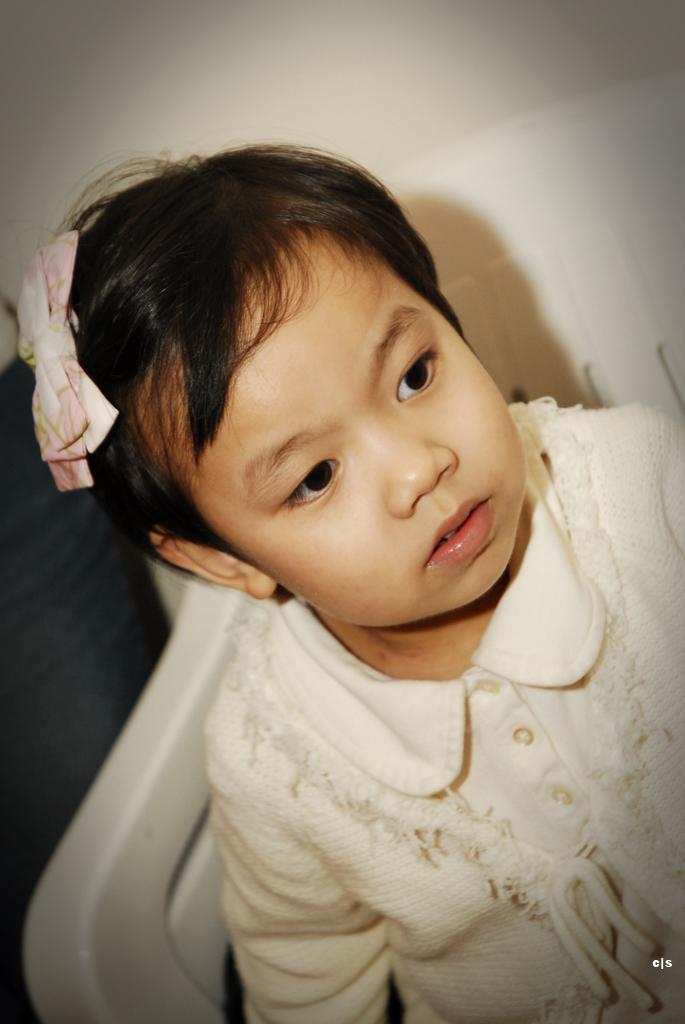Who is the main subject in the image? There is a girl in the image. What is the girl wearing? The girl is wearing a white dress. What is the girl sitting on? The girl is sitting on a white chair. What color is the wall in the background? The wall in the background is white. What is the color of the left side of the image? The left side of the image is black in color. What type of animal can be seen playing with an ornament on the girl's chair? There is no animal or ornament present on the girl's chair in the image. How many buttons are visible on the girl's dress? There are no buttons visible on the girl's dress in the image. 